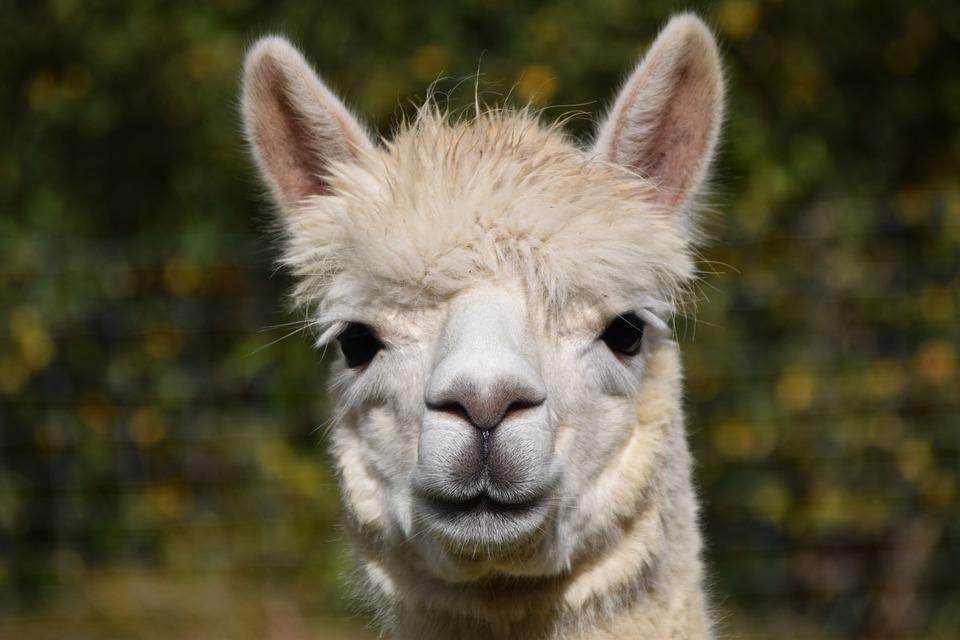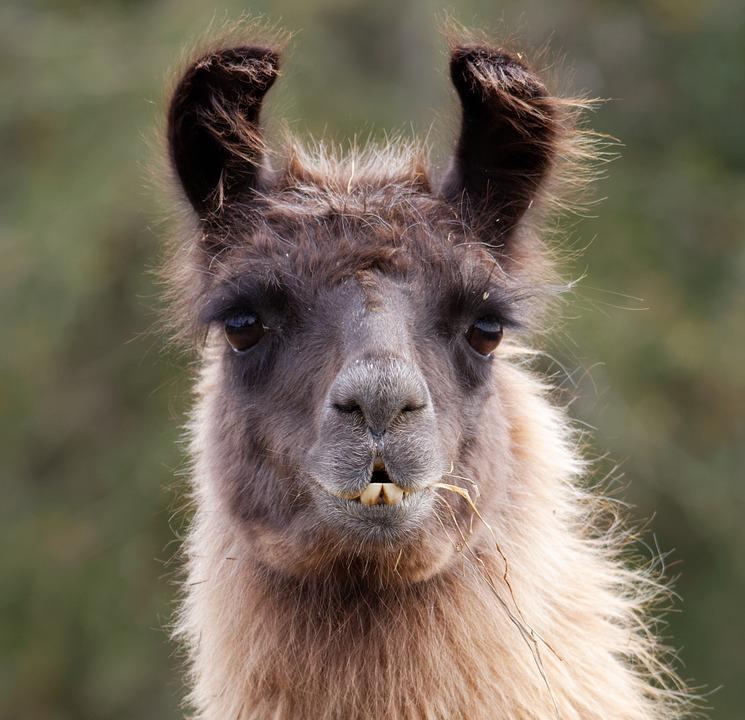The first image is the image on the left, the second image is the image on the right. Given the left and right images, does the statement "One image shows a forward-facing llama with dark ears and protruding lower teeth, and the other image shows a forward-facing white llama." hold true? Answer yes or no. Yes. 